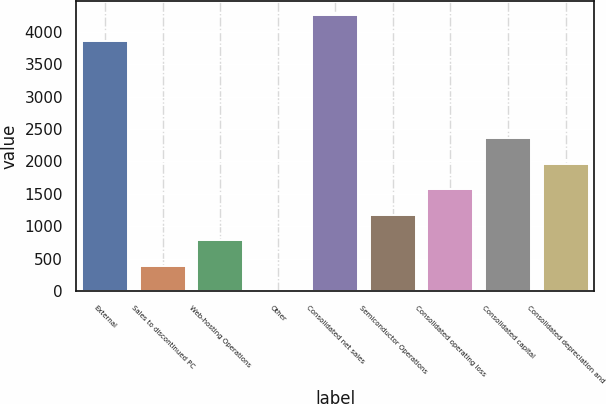Convert chart. <chart><loc_0><loc_0><loc_500><loc_500><bar_chart><fcel>External<fcel>Sales to discontinued PC<fcel>Web-hosting Operations<fcel>Other<fcel>Consolidated net sales<fcel>Semiconductor Operations<fcel>Consolidated operating loss<fcel>Consolidated capital<fcel>Consolidated depreciation and<nl><fcel>3861<fcel>393.86<fcel>787.42<fcel>0.3<fcel>4254.56<fcel>1180.98<fcel>1574.54<fcel>2361.66<fcel>1968.1<nl></chart> 